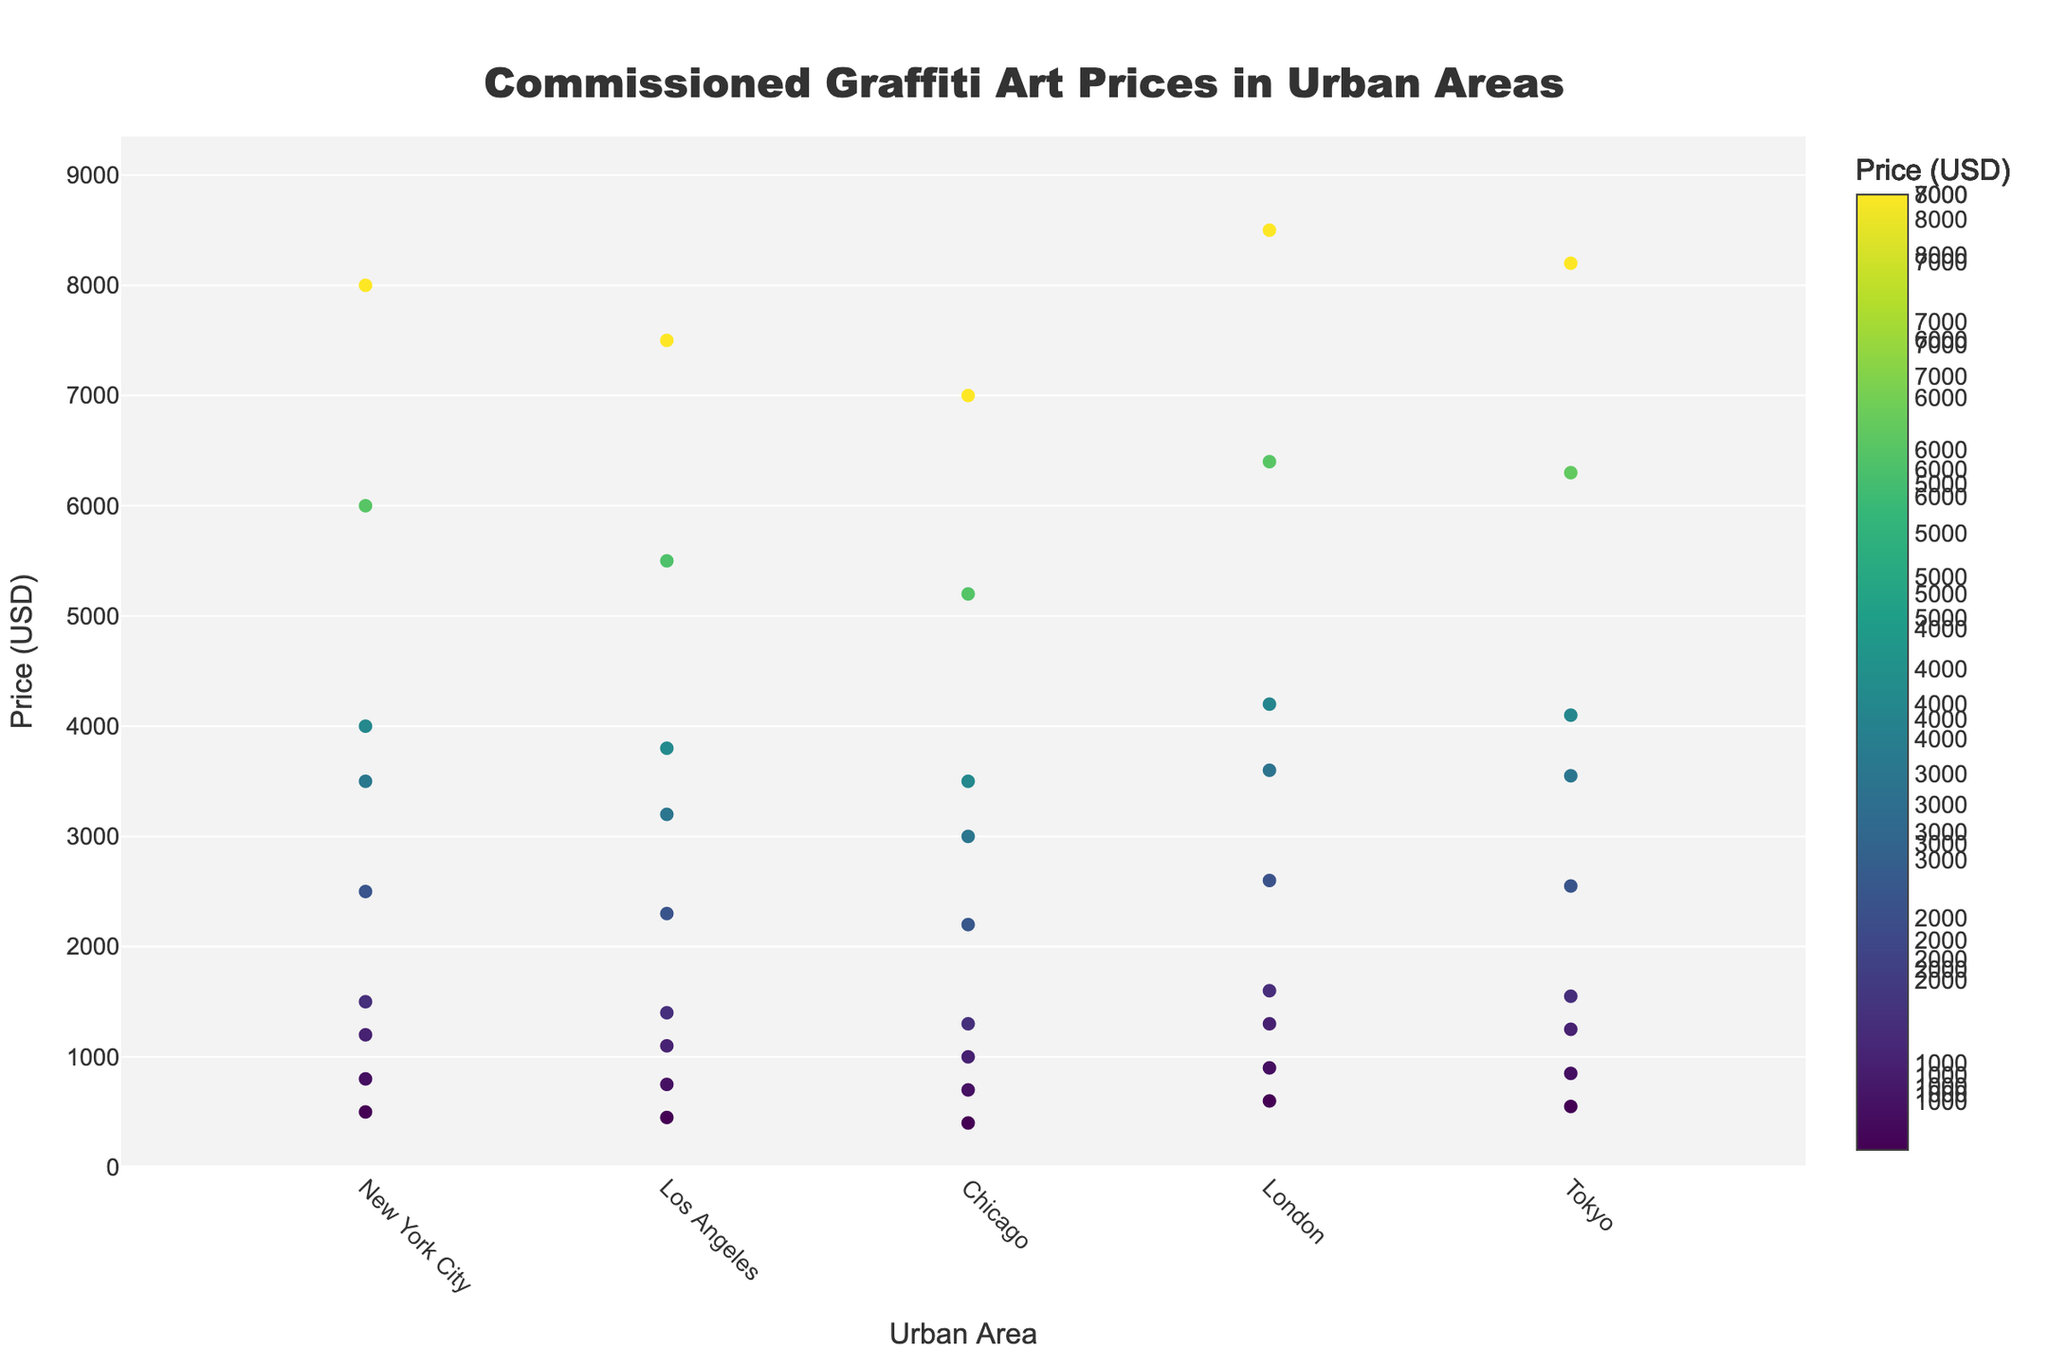What's the title of the figure? The title of the figure is displayed at the top. It reads 'Commissioned Graffiti Art Prices in Urban Areas'.
Answer: Commissioned Graffiti Art Prices in Urban Areas What's the x-axis label? The x-axis label is located below the horizontal axis. It reads 'Urban Area'.
Answer: Urban Area Which urban area has the highest median price for commissioned graffiti art? By examining the box plots, you can see which urban area has the highest median price by comparing the middle lines of each box. London has the highest median price since its middle line is the highest.
Answer: London How does the price distribution in New York City compare to that in Los Angeles? New York City's box plot is generally higher on the y-axis, indicating it has higher overall prices. The scatter points are more spread out in New York City, suggesting a wider distribution of prices compared to Los Angeles.
Answer: New York City generally has higher and more varied prices than Los Angeles What is the price range for small projects with low complexity in Chicago? By examining scatter points for small projects with low complexity in Chicago (noted through hover information), we see the prices are close to $400.
Answer: $400 Which urban area has the largest price range for medium-sized projects? By examining the spread of scatter points in the medium-sized project category for each urban area, London has the widest spread, ranging from $1600 to $3600.
Answer: London Are prices for commissioned graffiti art in Tokyo higher on average compared to Chicago? By comparing the overall height and distribution of scatter points in both Tokyo and Chicago, Tokyo's scatter points and overall box plot are generally higher, suggesting higher average prices.
Answer: Yes What color is generally used to show the price in the scatter plot? The scatter plot points are colored using a Viridis colorscale, which transitions from dark blue to bright yellow, indicating a range from lower to higher prices.
Answer: Viridis colorscale What's the highest price recorded in the dataset and in which urban area? The highest price can be identified by examining the highest scatter point. It is $8500 in London for large, high complexity projects.
Answer: $8500 in London How do price distributions differ between small and large projects in Tokyo? In Tokyo, small projects have a concentrated price range between $550 and $1250, while large projects show a wider spread from $4100 to $8200, indicating larger projects have higher and more varied prices.
Answer: Small projects have a narrow range, whereas large projects show higher and more varied prices 